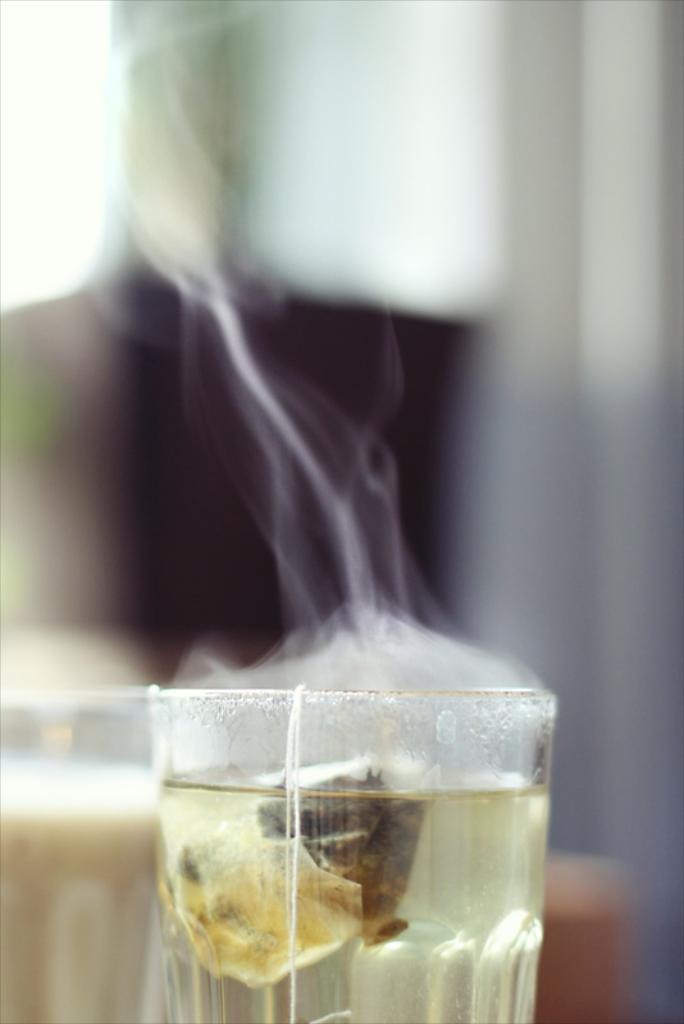Can you describe this image briefly? In this picture I can see the green cup and tea bag on it. Beside that I can see the tea glass. In the background I can see the blur image. 